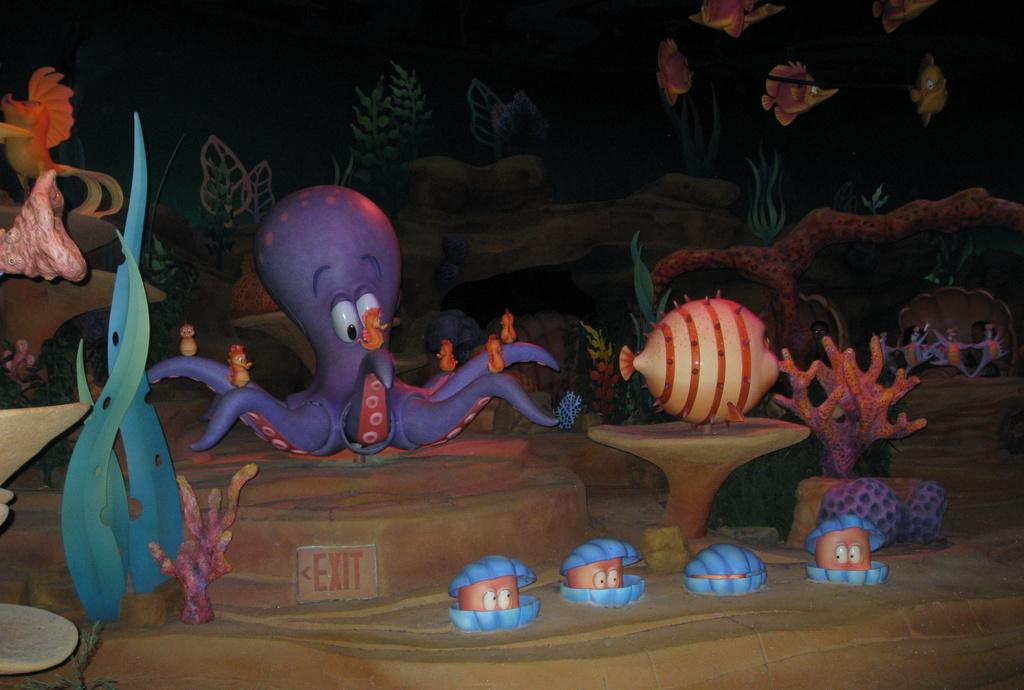What types of objects are present in the image? There are idols and toys in the image. Can you describe the idols in the image? Unfortunately, the details of the idols cannot be discerned from the provided facts. What kind of toys are visible in the image? The specific types of toys cannot be determined from the provided facts. What type of chin is visible on the creature in the image? There is no creature present in the image, so there is no chin to describe. 